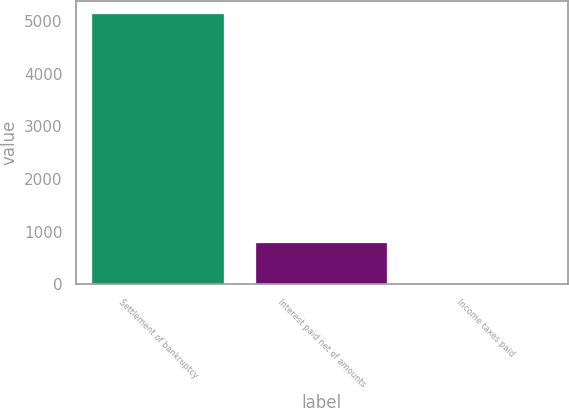<chart> <loc_0><loc_0><loc_500><loc_500><bar_chart><fcel>Settlement of bankruptcy<fcel>Interest paid net of amounts<fcel>Income taxes paid<nl><fcel>5131<fcel>780<fcel>4<nl></chart> 